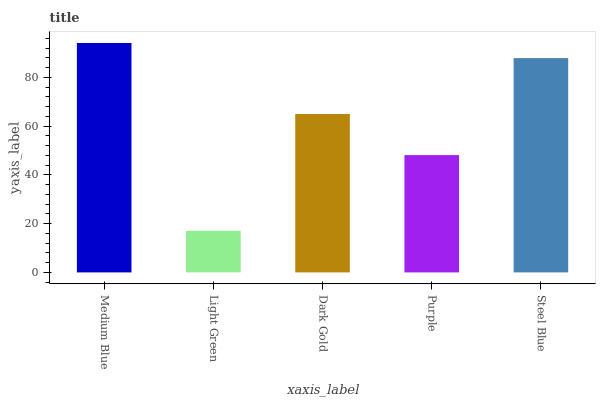Is Light Green the minimum?
Answer yes or no. Yes. Is Medium Blue the maximum?
Answer yes or no. Yes. Is Dark Gold the minimum?
Answer yes or no. No. Is Dark Gold the maximum?
Answer yes or no. No. Is Dark Gold greater than Light Green?
Answer yes or no. Yes. Is Light Green less than Dark Gold?
Answer yes or no. Yes. Is Light Green greater than Dark Gold?
Answer yes or no. No. Is Dark Gold less than Light Green?
Answer yes or no. No. Is Dark Gold the high median?
Answer yes or no. Yes. Is Dark Gold the low median?
Answer yes or no. Yes. Is Medium Blue the high median?
Answer yes or no. No. Is Purple the low median?
Answer yes or no. No. 